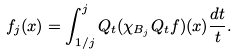<formula> <loc_0><loc_0><loc_500><loc_500>f _ { j } ( x ) = \int _ { 1 / j } ^ { j } Q _ { t } ( \chi _ { B _ { j } } Q _ { t } f ) ( x ) \frac { d t } { t } .</formula> 